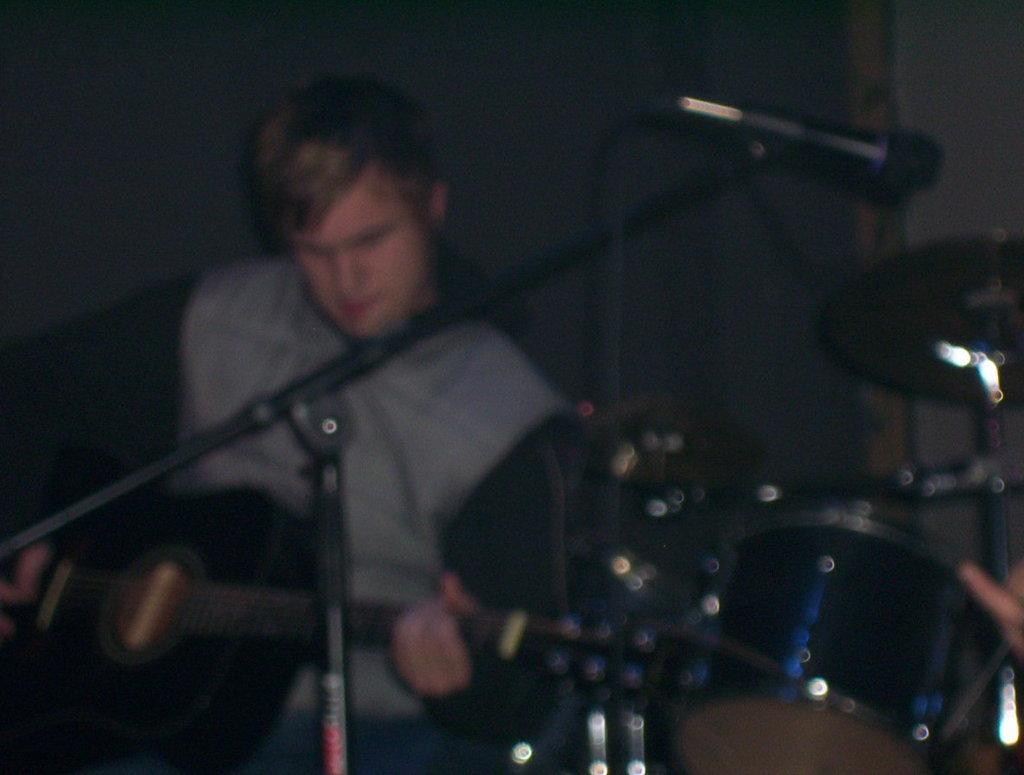What is the main subject of the image? There is a man standing in the center of the image. What is the man holding in his hand? The man is holding a guitar in his hand. What object is placed before the man? There is a microphone placed before the man. What can be seen on the right side of the image? There is a band on the right side of the image. What type of sink can be seen in the background of the image? There is no sink present in the image. What day of the week is it in the image? The day of the week cannot be determined from the image. 